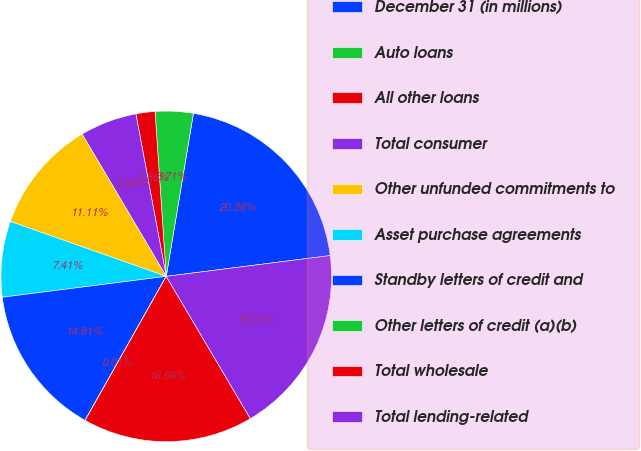<chart> <loc_0><loc_0><loc_500><loc_500><pie_chart><fcel>December 31 (in millions)<fcel>Auto loans<fcel>All other loans<fcel>Total consumer<fcel>Other unfunded commitments to<fcel>Asset purchase agreements<fcel>Standby letters of credit and<fcel>Other letters of credit (a)(b)<fcel>Total wholesale<fcel>Total lending-related<nl><fcel>20.36%<fcel>3.71%<fcel>1.86%<fcel>5.56%<fcel>11.11%<fcel>7.41%<fcel>14.81%<fcel>0.01%<fcel>16.66%<fcel>18.51%<nl></chart> 